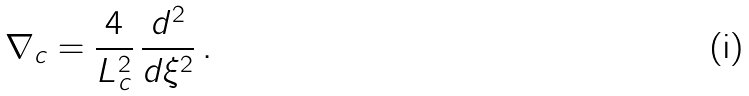<formula> <loc_0><loc_0><loc_500><loc_500>\nabla _ { c } = \frac { 4 } { L _ { c } ^ { 2 } } \, \frac { d ^ { 2 } } { d \xi ^ { 2 } } \, .</formula> 